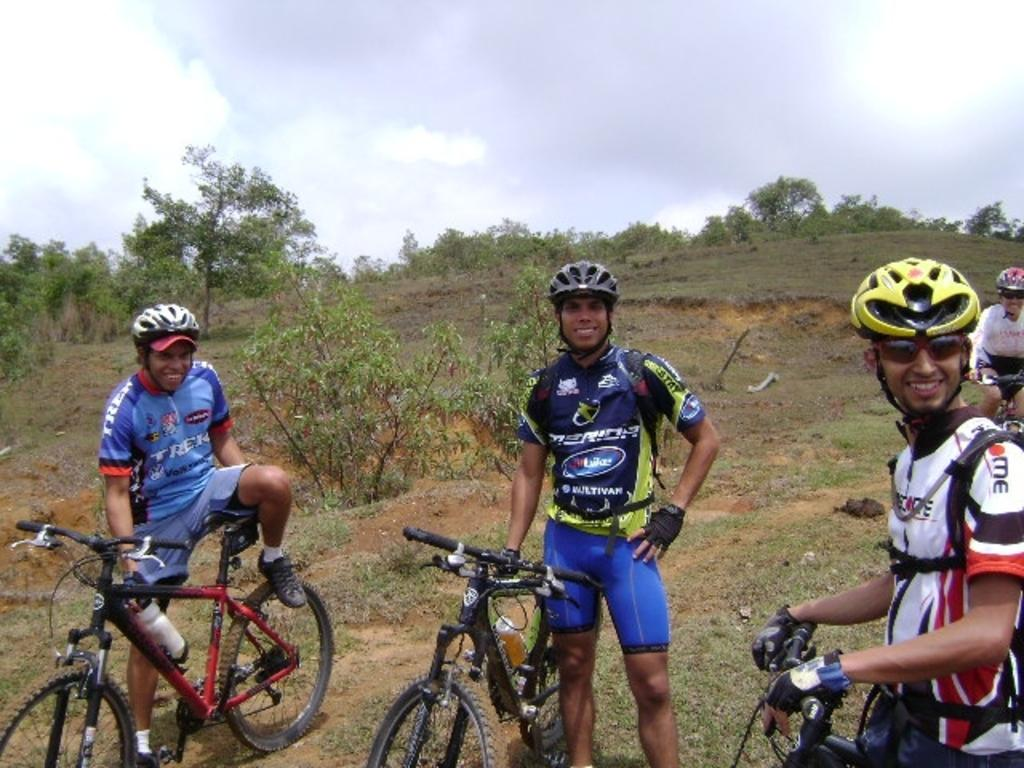What are the people in the image doing? The persons in the image are standing and sitting on bicycles. What can be seen in the background of the image? There are trees in the background of the image. How would you describe the weather in the image? The sky is cloudy in the image. What is the mood of the people in the image? The persons in the image are smiling, which suggests a positive mood. What type of salt is being used to season the trucks in the image? There are no trucks or salt present in the image. The image features people on bicycles with trees and a cloudy sky in the background. 